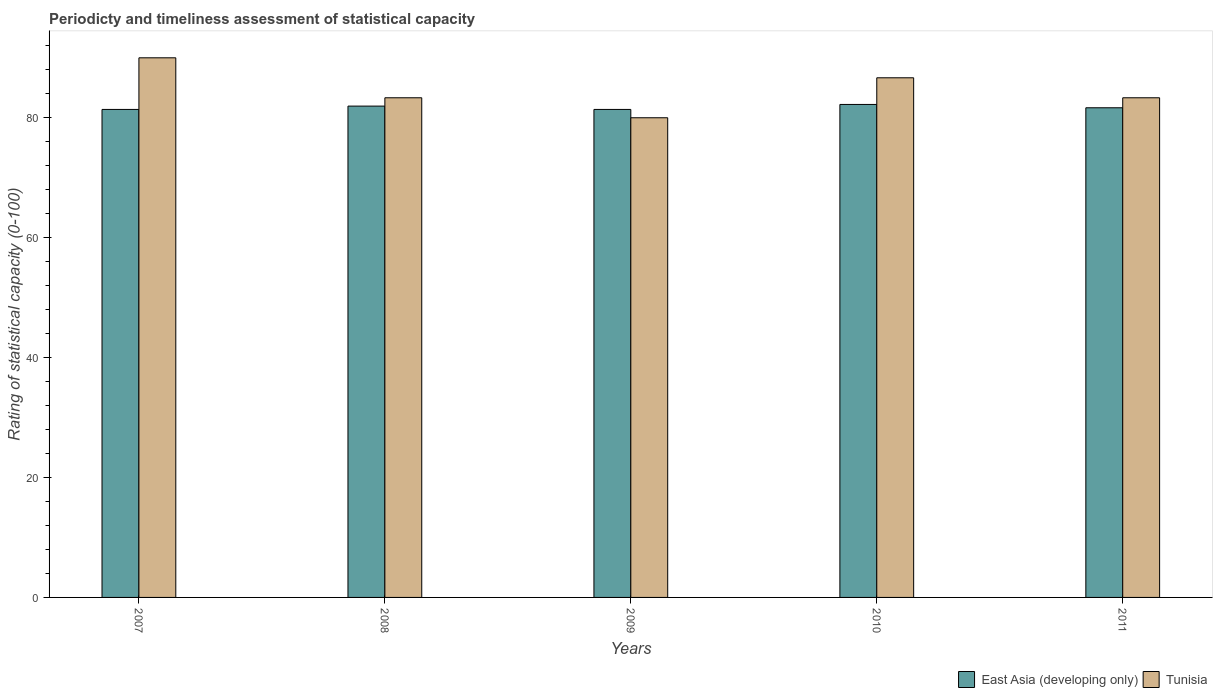Are the number of bars on each tick of the X-axis equal?
Offer a terse response. Yes. How many bars are there on the 5th tick from the left?
Your response must be concise. 2. In how many cases, is the number of bars for a given year not equal to the number of legend labels?
Offer a very short reply. 0. What is the rating of statistical capacity in Tunisia in 2011?
Your response must be concise. 83.33. Across all years, what is the maximum rating of statistical capacity in East Asia (developing only)?
Your answer should be very brief. 82.22. Across all years, what is the minimum rating of statistical capacity in Tunisia?
Make the answer very short. 80. In which year was the rating of statistical capacity in East Asia (developing only) maximum?
Your response must be concise. 2010. In which year was the rating of statistical capacity in Tunisia minimum?
Offer a terse response. 2009. What is the total rating of statistical capacity in Tunisia in the graph?
Provide a short and direct response. 423.33. What is the difference between the rating of statistical capacity in Tunisia in 2010 and that in 2011?
Your answer should be very brief. 3.33. What is the difference between the rating of statistical capacity in East Asia (developing only) in 2011 and the rating of statistical capacity in Tunisia in 2010?
Your answer should be very brief. -5. What is the average rating of statistical capacity in East Asia (developing only) per year?
Offer a terse response. 81.72. In the year 2007, what is the difference between the rating of statistical capacity in Tunisia and rating of statistical capacity in East Asia (developing only)?
Ensure brevity in your answer.  8.61. In how many years, is the rating of statistical capacity in East Asia (developing only) greater than 36?
Provide a short and direct response. 5. What is the ratio of the rating of statistical capacity in Tunisia in 2007 to that in 2009?
Provide a succinct answer. 1.12. Is the rating of statistical capacity in East Asia (developing only) in 2007 less than that in 2009?
Provide a short and direct response. Yes. What is the difference between the highest and the second highest rating of statistical capacity in East Asia (developing only)?
Your response must be concise. 0.28. What is the difference between the highest and the lowest rating of statistical capacity in East Asia (developing only)?
Offer a very short reply. 0.83. Is the sum of the rating of statistical capacity in East Asia (developing only) in 2009 and 2010 greater than the maximum rating of statistical capacity in Tunisia across all years?
Keep it short and to the point. Yes. What does the 1st bar from the left in 2008 represents?
Make the answer very short. East Asia (developing only). What does the 1st bar from the right in 2011 represents?
Give a very brief answer. Tunisia. How many bars are there?
Ensure brevity in your answer.  10. Are the values on the major ticks of Y-axis written in scientific E-notation?
Your answer should be very brief. No. Where does the legend appear in the graph?
Provide a short and direct response. Bottom right. How many legend labels are there?
Provide a short and direct response. 2. What is the title of the graph?
Your answer should be very brief. Periodicty and timeliness assessment of statistical capacity. Does "Arab World" appear as one of the legend labels in the graph?
Your response must be concise. No. What is the label or title of the Y-axis?
Provide a succinct answer. Rating of statistical capacity (0-100). What is the Rating of statistical capacity (0-100) of East Asia (developing only) in 2007?
Provide a short and direct response. 81.39. What is the Rating of statistical capacity (0-100) in East Asia (developing only) in 2008?
Your answer should be very brief. 81.94. What is the Rating of statistical capacity (0-100) of Tunisia in 2008?
Provide a succinct answer. 83.33. What is the Rating of statistical capacity (0-100) of East Asia (developing only) in 2009?
Ensure brevity in your answer.  81.39. What is the Rating of statistical capacity (0-100) in East Asia (developing only) in 2010?
Your answer should be compact. 82.22. What is the Rating of statistical capacity (0-100) of Tunisia in 2010?
Provide a succinct answer. 86.67. What is the Rating of statistical capacity (0-100) of East Asia (developing only) in 2011?
Your answer should be very brief. 81.67. What is the Rating of statistical capacity (0-100) of Tunisia in 2011?
Provide a succinct answer. 83.33. Across all years, what is the maximum Rating of statistical capacity (0-100) in East Asia (developing only)?
Your answer should be compact. 82.22. Across all years, what is the minimum Rating of statistical capacity (0-100) in East Asia (developing only)?
Make the answer very short. 81.39. Across all years, what is the minimum Rating of statistical capacity (0-100) of Tunisia?
Your answer should be very brief. 80. What is the total Rating of statistical capacity (0-100) of East Asia (developing only) in the graph?
Your answer should be very brief. 408.61. What is the total Rating of statistical capacity (0-100) of Tunisia in the graph?
Provide a short and direct response. 423.33. What is the difference between the Rating of statistical capacity (0-100) of East Asia (developing only) in 2007 and that in 2008?
Provide a short and direct response. -0.56. What is the difference between the Rating of statistical capacity (0-100) in Tunisia in 2007 and that in 2009?
Give a very brief answer. 10. What is the difference between the Rating of statistical capacity (0-100) in Tunisia in 2007 and that in 2010?
Provide a succinct answer. 3.33. What is the difference between the Rating of statistical capacity (0-100) in East Asia (developing only) in 2007 and that in 2011?
Keep it short and to the point. -0.28. What is the difference between the Rating of statistical capacity (0-100) of Tunisia in 2007 and that in 2011?
Offer a very short reply. 6.67. What is the difference between the Rating of statistical capacity (0-100) of East Asia (developing only) in 2008 and that in 2009?
Offer a very short reply. 0.56. What is the difference between the Rating of statistical capacity (0-100) of Tunisia in 2008 and that in 2009?
Keep it short and to the point. 3.33. What is the difference between the Rating of statistical capacity (0-100) of East Asia (developing only) in 2008 and that in 2010?
Your response must be concise. -0.28. What is the difference between the Rating of statistical capacity (0-100) in Tunisia in 2008 and that in 2010?
Keep it short and to the point. -3.33. What is the difference between the Rating of statistical capacity (0-100) in East Asia (developing only) in 2008 and that in 2011?
Offer a very short reply. 0.28. What is the difference between the Rating of statistical capacity (0-100) in Tunisia in 2009 and that in 2010?
Your answer should be compact. -6.67. What is the difference between the Rating of statistical capacity (0-100) of East Asia (developing only) in 2009 and that in 2011?
Keep it short and to the point. -0.28. What is the difference between the Rating of statistical capacity (0-100) of East Asia (developing only) in 2010 and that in 2011?
Offer a terse response. 0.56. What is the difference between the Rating of statistical capacity (0-100) in Tunisia in 2010 and that in 2011?
Make the answer very short. 3.33. What is the difference between the Rating of statistical capacity (0-100) in East Asia (developing only) in 2007 and the Rating of statistical capacity (0-100) in Tunisia in 2008?
Your answer should be very brief. -1.94. What is the difference between the Rating of statistical capacity (0-100) in East Asia (developing only) in 2007 and the Rating of statistical capacity (0-100) in Tunisia in 2009?
Your response must be concise. 1.39. What is the difference between the Rating of statistical capacity (0-100) in East Asia (developing only) in 2007 and the Rating of statistical capacity (0-100) in Tunisia in 2010?
Keep it short and to the point. -5.28. What is the difference between the Rating of statistical capacity (0-100) in East Asia (developing only) in 2007 and the Rating of statistical capacity (0-100) in Tunisia in 2011?
Provide a succinct answer. -1.94. What is the difference between the Rating of statistical capacity (0-100) of East Asia (developing only) in 2008 and the Rating of statistical capacity (0-100) of Tunisia in 2009?
Provide a short and direct response. 1.94. What is the difference between the Rating of statistical capacity (0-100) in East Asia (developing only) in 2008 and the Rating of statistical capacity (0-100) in Tunisia in 2010?
Keep it short and to the point. -4.72. What is the difference between the Rating of statistical capacity (0-100) of East Asia (developing only) in 2008 and the Rating of statistical capacity (0-100) of Tunisia in 2011?
Offer a very short reply. -1.39. What is the difference between the Rating of statistical capacity (0-100) of East Asia (developing only) in 2009 and the Rating of statistical capacity (0-100) of Tunisia in 2010?
Your answer should be compact. -5.28. What is the difference between the Rating of statistical capacity (0-100) of East Asia (developing only) in 2009 and the Rating of statistical capacity (0-100) of Tunisia in 2011?
Provide a short and direct response. -1.94. What is the difference between the Rating of statistical capacity (0-100) of East Asia (developing only) in 2010 and the Rating of statistical capacity (0-100) of Tunisia in 2011?
Make the answer very short. -1.11. What is the average Rating of statistical capacity (0-100) in East Asia (developing only) per year?
Provide a succinct answer. 81.72. What is the average Rating of statistical capacity (0-100) in Tunisia per year?
Ensure brevity in your answer.  84.67. In the year 2007, what is the difference between the Rating of statistical capacity (0-100) of East Asia (developing only) and Rating of statistical capacity (0-100) of Tunisia?
Provide a short and direct response. -8.61. In the year 2008, what is the difference between the Rating of statistical capacity (0-100) of East Asia (developing only) and Rating of statistical capacity (0-100) of Tunisia?
Your response must be concise. -1.39. In the year 2009, what is the difference between the Rating of statistical capacity (0-100) in East Asia (developing only) and Rating of statistical capacity (0-100) in Tunisia?
Keep it short and to the point. 1.39. In the year 2010, what is the difference between the Rating of statistical capacity (0-100) in East Asia (developing only) and Rating of statistical capacity (0-100) in Tunisia?
Offer a very short reply. -4.44. In the year 2011, what is the difference between the Rating of statistical capacity (0-100) of East Asia (developing only) and Rating of statistical capacity (0-100) of Tunisia?
Provide a succinct answer. -1.67. What is the ratio of the Rating of statistical capacity (0-100) of East Asia (developing only) in 2007 to that in 2008?
Ensure brevity in your answer.  0.99. What is the ratio of the Rating of statistical capacity (0-100) in Tunisia in 2007 to that in 2008?
Offer a terse response. 1.08. What is the ratio of the Rating of statistical capacity (0-100) of East Asia (developing only) in 2007 to that in 2011?
Provide a succinct answer. 1. What is the ratio of the Rating of statistical capacity (0-100) in East Asia (developing only) in 2008 to that in 2009?
Keep it short and to the point. 1.01. What is the ratio of the Rating of statistical capacity (0-100) in Tunisia in 2008 to that in 2009?
Your answer should be compact. 1.04. What is the ratio of the Rating of statistical capacity (0-100) in East Asia (developing only) in 2008 to that in 2010?
Provide a succinct answer. 1. What is the ratio of the Rating of statistical capacity (0-100) in Tunisia in 2008 to that in 2010?
Give a very brief answer. 0.96. What is the ratio of the Rating of statistical capacity (0-100) of Tunisia in 2008 to that in 2011?
Keep it short and to the point. 1. What is the ratio of the Rating of statistical capacity (0-100) in East Asia (developing only) in 2009 to that in 2011?
Provide a succinct answer. 1. What is the ratio of the Rating of statistical capacity (0-100) in Tunisia in 2009 to that in 2011?
Keep it short and to the point. 0.96. What is the ratio of the Rating of statistical capacity (0-100) of East Asia (developing only) in 2010 to that in 2011?
Offer a terse response. 1.01. What is the difference between the highest and the second highest Rating of statistical capacity (0-100) in East Asia (developing only)?
Keep it short and to the point. 0.28. What is the difference between the highest and the second highest Rating of statistical capacity (0-100) in Tunisia?
Keep it short and to the point. 3.33. 